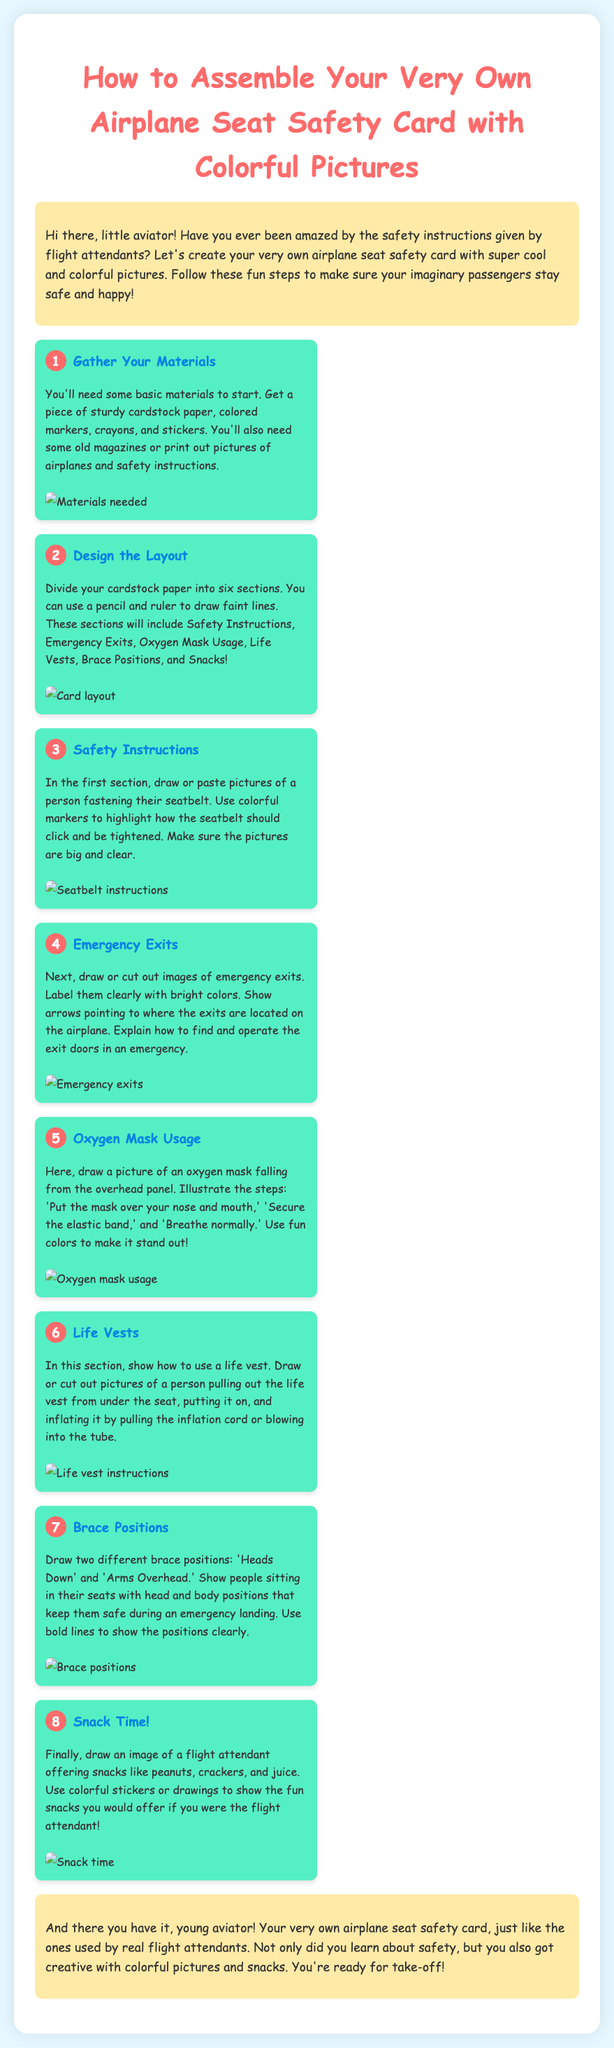What materials do you need? The materials listed for assembling the safety card include cardstock paper, colored markers, crayons, stickers, and old magazines or printed pictures.
Answer: cardstock paper, colored markers, crayons, stickers, old magazines How many sections should the cardstock paper be divided into? The instructions state that the cardstock paper should be divided into six sections for various topics.
Answer: six What is the first section about? The first section focuses on Safety Instructions, specifically about fastening seatbelts.
Answer: Safety Instructions Which picture is in the section for Oxygen Mask Usage? The document instructs to illustrate a picture of an oxygen mask falling from the overhead panel.
Answer: oxygen mask falling What color should the arrows be for labeling emergency exits? The document suggests using bright colors to label emergency exits clearly.
Answer: bright colors How many brace positions are illustrated? The instructions describe two different brace positions: Heads Down and Arms Overhead.
Answer: two What fun item is offered at the end of the safety card? The last section of the card shows a flight attendant offering snacks.
Answer: snacks What is the title of the assembly instructions? The title at the top of the document indicates it is about assembling an airplane seat safety card.
Answer: How to Assemble Your Very Own Airplane Seat Safety Card with Colorful Pictures 